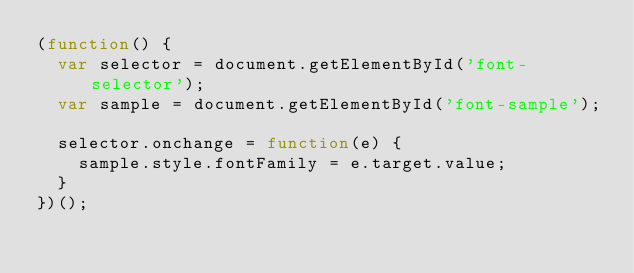Convert code to text. <code><loc_0><loc_0><loc_500><loc_500><_JavaScript_>(function() {
  var selector = document.getElementById('font-selector');
  var sample = document.getElementById('font-sample');

  selector.onchange = function(e) {
    sample.style.fontFamily = e.target.value;
  }
})();</code> 